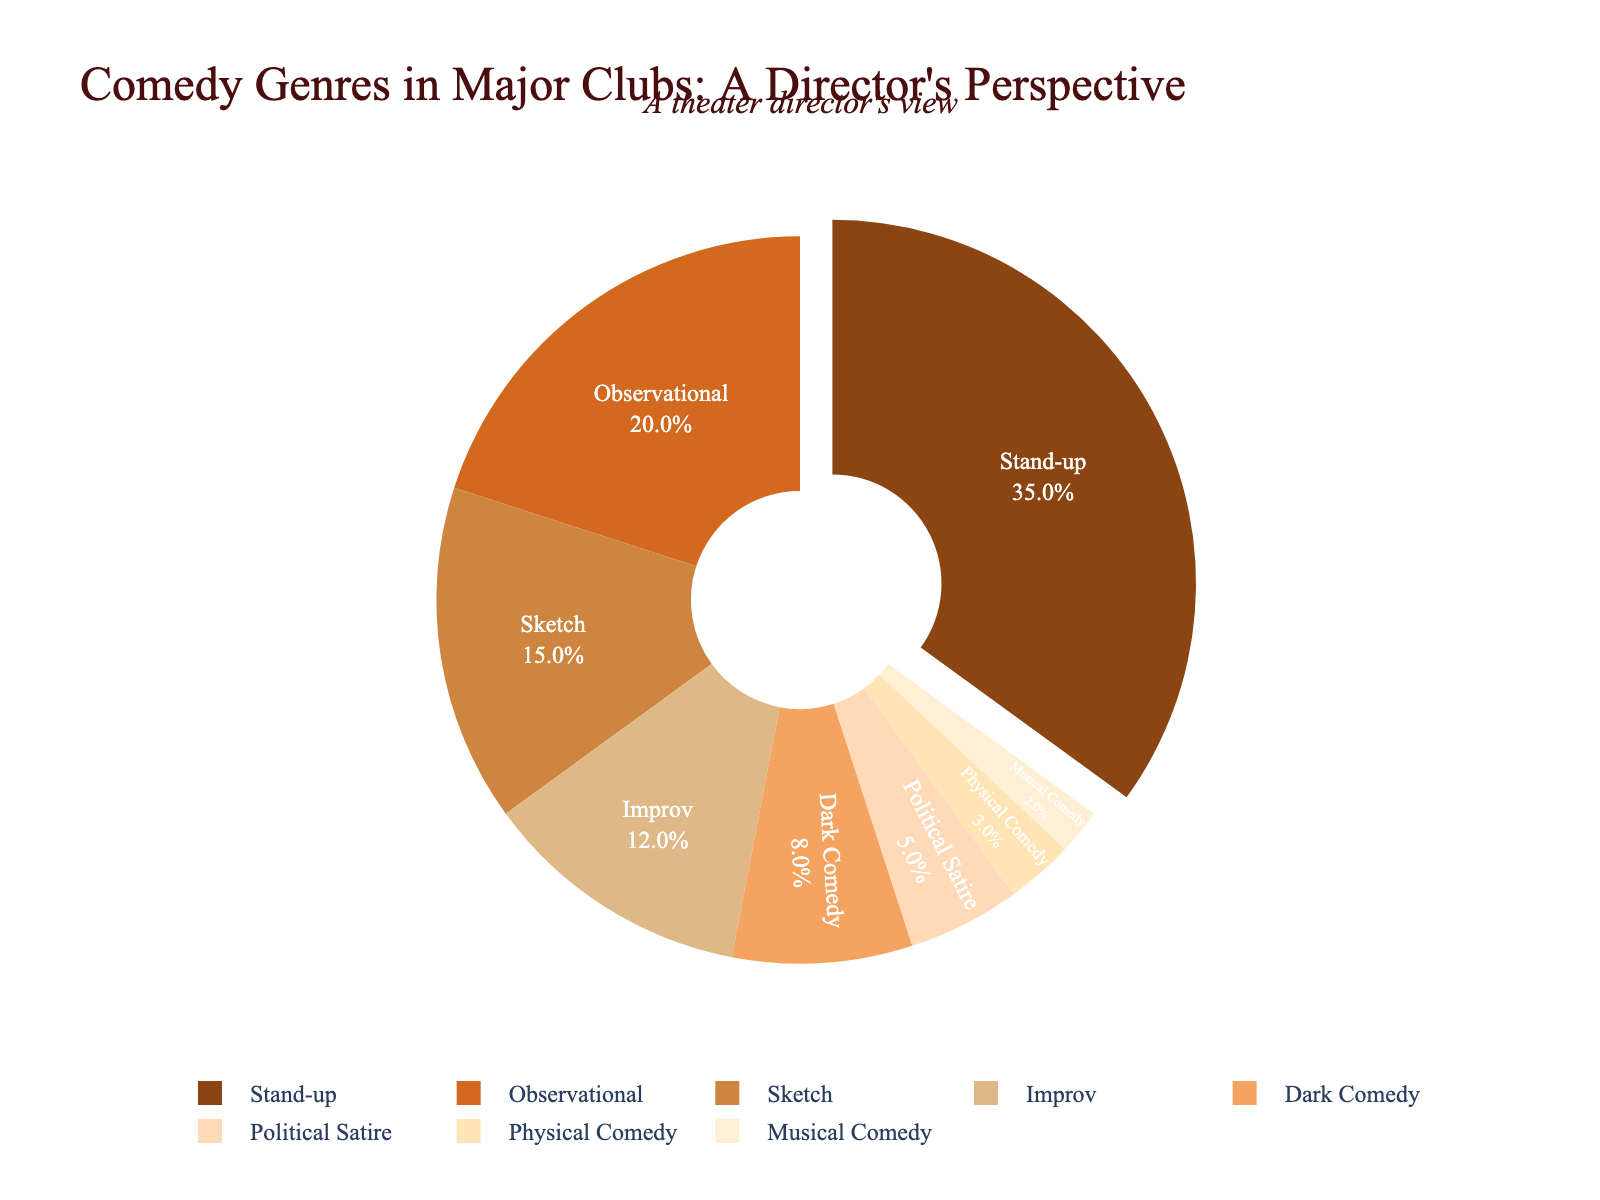What's the most performed comedy genre in major clubs? The pie chart shows different comedy genres, with "Stand-up" occupying the largest section. Stand-up has the highest percentage.
Answer: Stand-up Which genre is performed less, Political Satire or Physical Comedy? The pie chart assigns 5% to Political Satire and 3% to Physical Comedy. 3% is less than 5%.
Answer: Physical Comedy What is the combined percentage of Sketch and Improv genres? Sketch contributes 15% and Improv contributes 12%. Summing them up gives 15 + 12 = 27%.
Answer: 27% How does the percentage of Observational compare to Dark Comedy? Observational comedy has a 20% share, while Dark Comedy has 8%. 20% is greater than 8%.
Answer: Observational is larger What percentage of the chart is taken up by Musical Comedy? The pie chart indicates that Musical Comedy accounts for 2% of the comedy genres.
Answer: 2% Is Observational Comedy more popular than Sketch and Musical Comedy combined? Observational has 20%. Sketch and Musical Comedy together are 15% + 2%= 17%. 20% is more than 17%.
Answer: Yes What is the percentage difference between Stand-up and Improv comedy? Stand-up has 35%, while Improv has 12%. The difference is 35 - 12 = 23%.
Answer: 23% Which genre has the smallest percentage, and what is that percentage? Musical Comedy occupies the smallest section of the pie chart at 2%.
Answer: Musical Comedy with 2% Are there more genres with a percentage below 10% or above 10%? Below 10%, there are Dark Comedy (8%), Political Satire (5%), Physical Comedy (3%), and Musical Comedy (2%)—4 in total. Above 10%, there are Stand-up (35%), Observational (20%), Sketch (15%), and Improv (12%)—4 in total. Both are equal.
Answer: Equal What is the total percentage of all comedy genres that the theater director would possibly consider more "serious" (e.g., Dark Comedy, Political Satire)? Dark Comedy is 8%, and Political Satire is 5%. Summing them up yields 8 + 5 = 13%.
Answer: 13% 